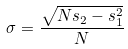Convert formula to latex. <formula><loc_0><loc_0><loc_500><loc_500>\sigma = \frac { \sqrt { N s _ { 2 } - s _ { 1 } ^ { 2 } } } { N }</formula> 